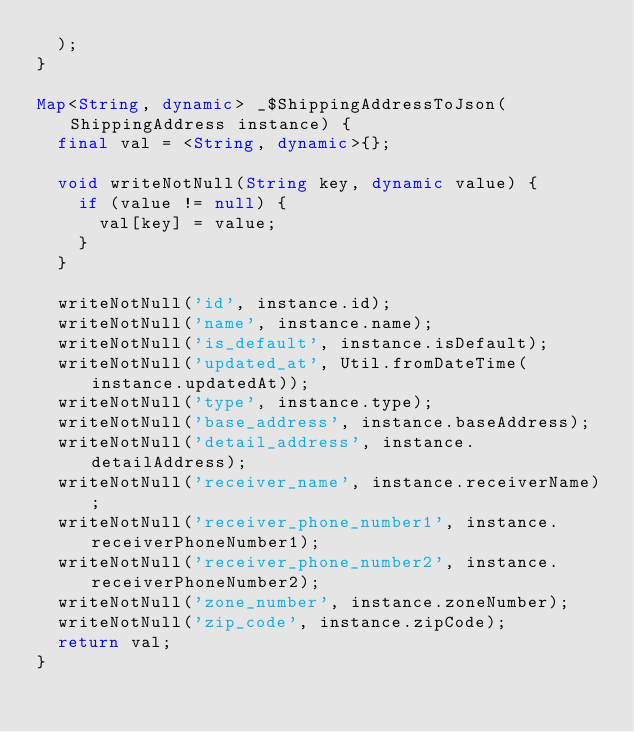<code> <loc_0><loc_0><loc_500><loc_500><_Dart_>  );
}

Map<String, dynamic> _$ShippingAddressToJson(ShippingAddress instance) {
  final val = <String, dynamic>{};

  void writeNotNull(String key, dynamic value) {
    if (value != null) {
      val[key] = value;
    }
  }

  writeNotNull('id', instance.id);
  writeNotNull('name', instance.name);
  writeNotNull('is_default', instance.isDefault);
  writeNotNull('updated_at', Util.fromDateTime(instance.updatedAt));
  writeNotNull('type', instance.type);
  writeNotNull('base_address', instance.baseAddress);
  writeNotNull('detail_address', instance.detailAddress);
  writeNotNull('receiver_name', instance.receiverName);
  writeNotNull('receiver_phone_number1', instance.receiverPhoneNumber1);
  writeNotNull('receiver_phone_number2', instance.receiverPhoneNumber2);
  writeNotNull('zone_number', instance.zoneNumber);
  writeNotNull('zip_code', instance.zipCode);
  return val;
}
</code> 